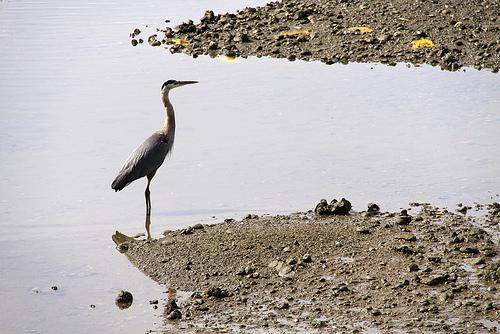Question: what is the bird standing on?
Choices:
A. Perch.
B. Crane.
C. Branch.
D. The beach.
Answer with the letter. Answer: D 